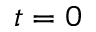<formula> <loc_0><loc_0><loc_500><loc_500>t = 0</formula> 